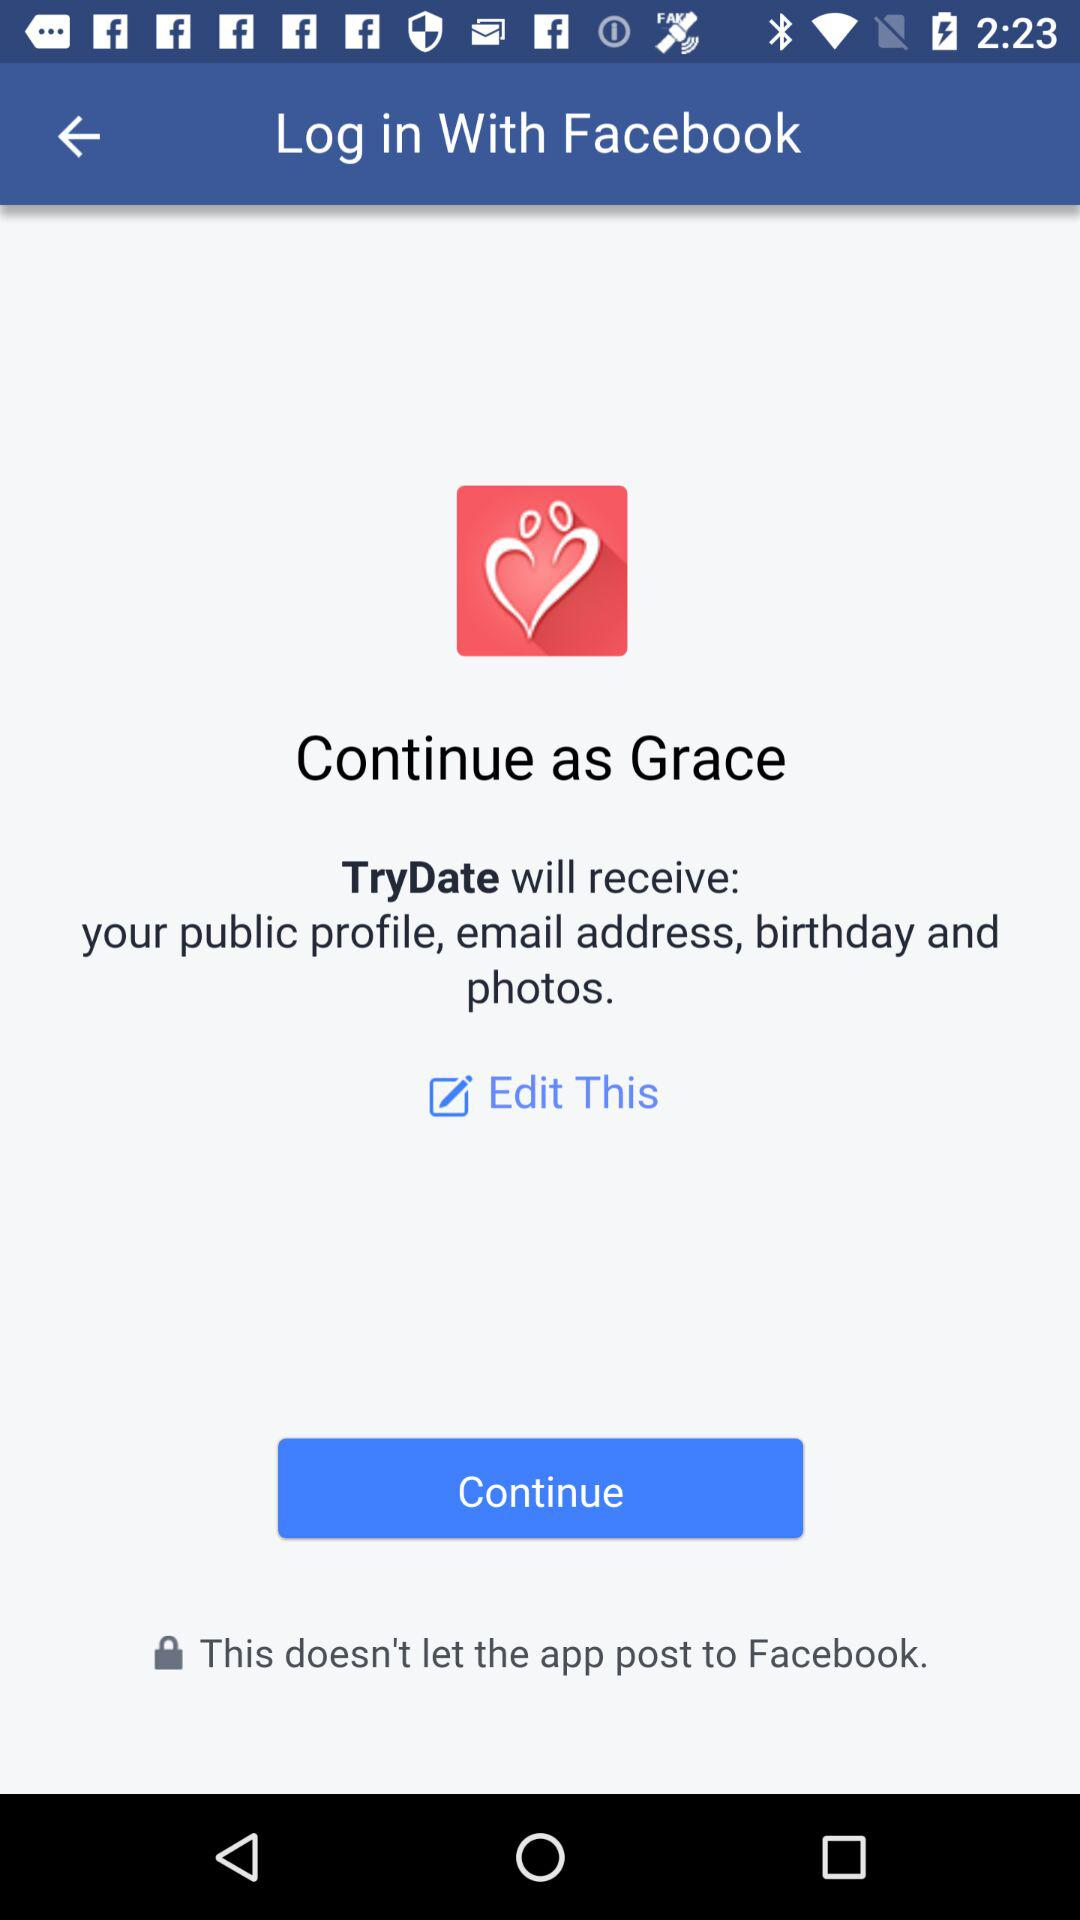What is the user name? The user name is "Grace". 